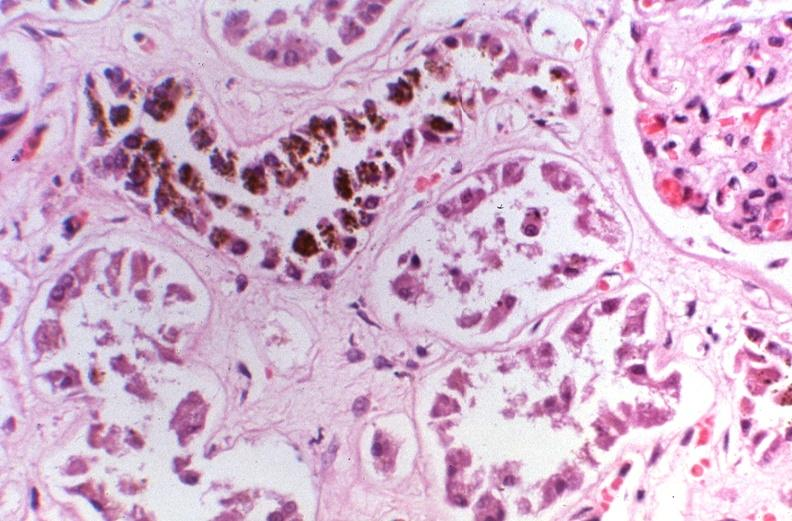does pulmonary osteoarthropathy show kidney, hemochromatosis?
Answer the question using a single word or phrase. No 